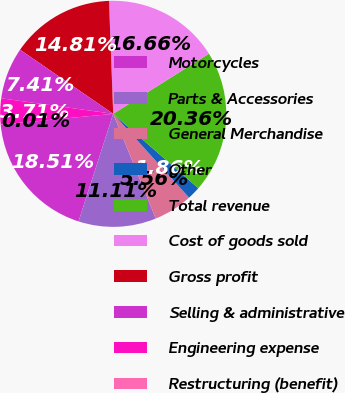Convert chart to OTSL. <chart><loc_0><loc_0><loc_500><loc_500><pie_chart><fcel>Motorcycles<fcel>Parts & Accessories<fcel>General Merchandise<fcel>Other<fcel>Total revenue<fcel>Cost of goods sold<fcel>Gross profit<fcel>Selling & administrative<fcel>Engineering expense<fcel>Restructuring (benefit)<nl><fcel>18.51%<fcel>11.11%<fcel>5.56%<fcel>1.86%<fcel>20.36%<fcel>16.66%<fcel>14.81%<fcel>7.41%<fcel>3.71%<fcel>0.01%<nl></chart> 